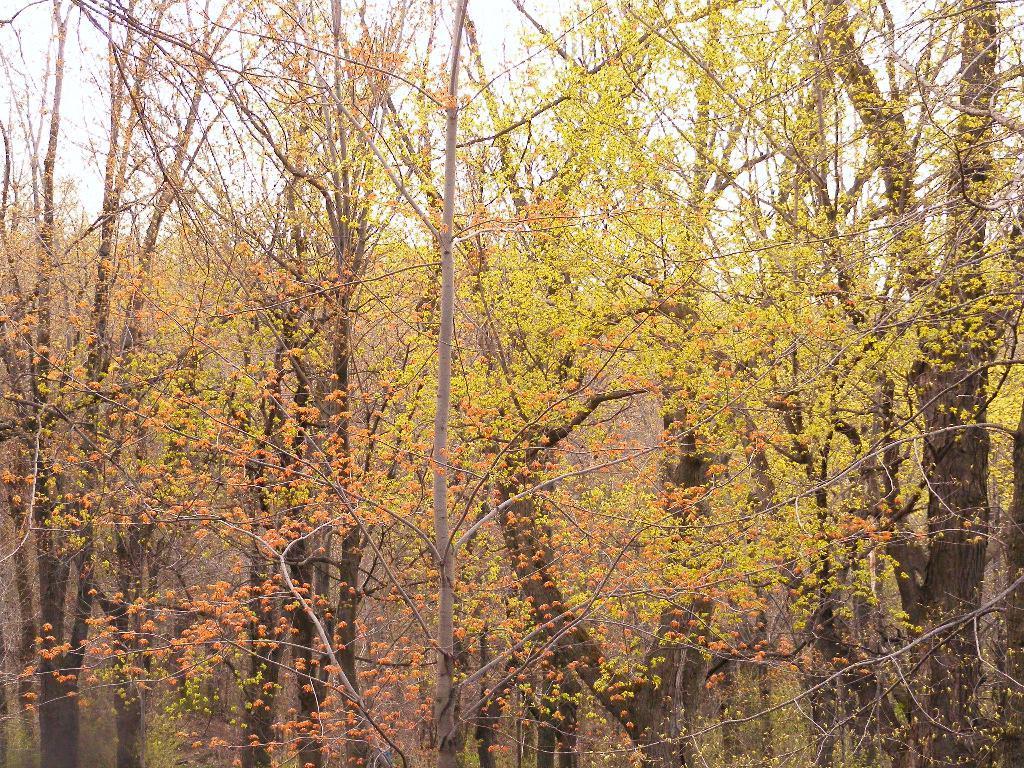Describe this image in one or two sentences. In this image I can see yellow color trees and the sky visible. 